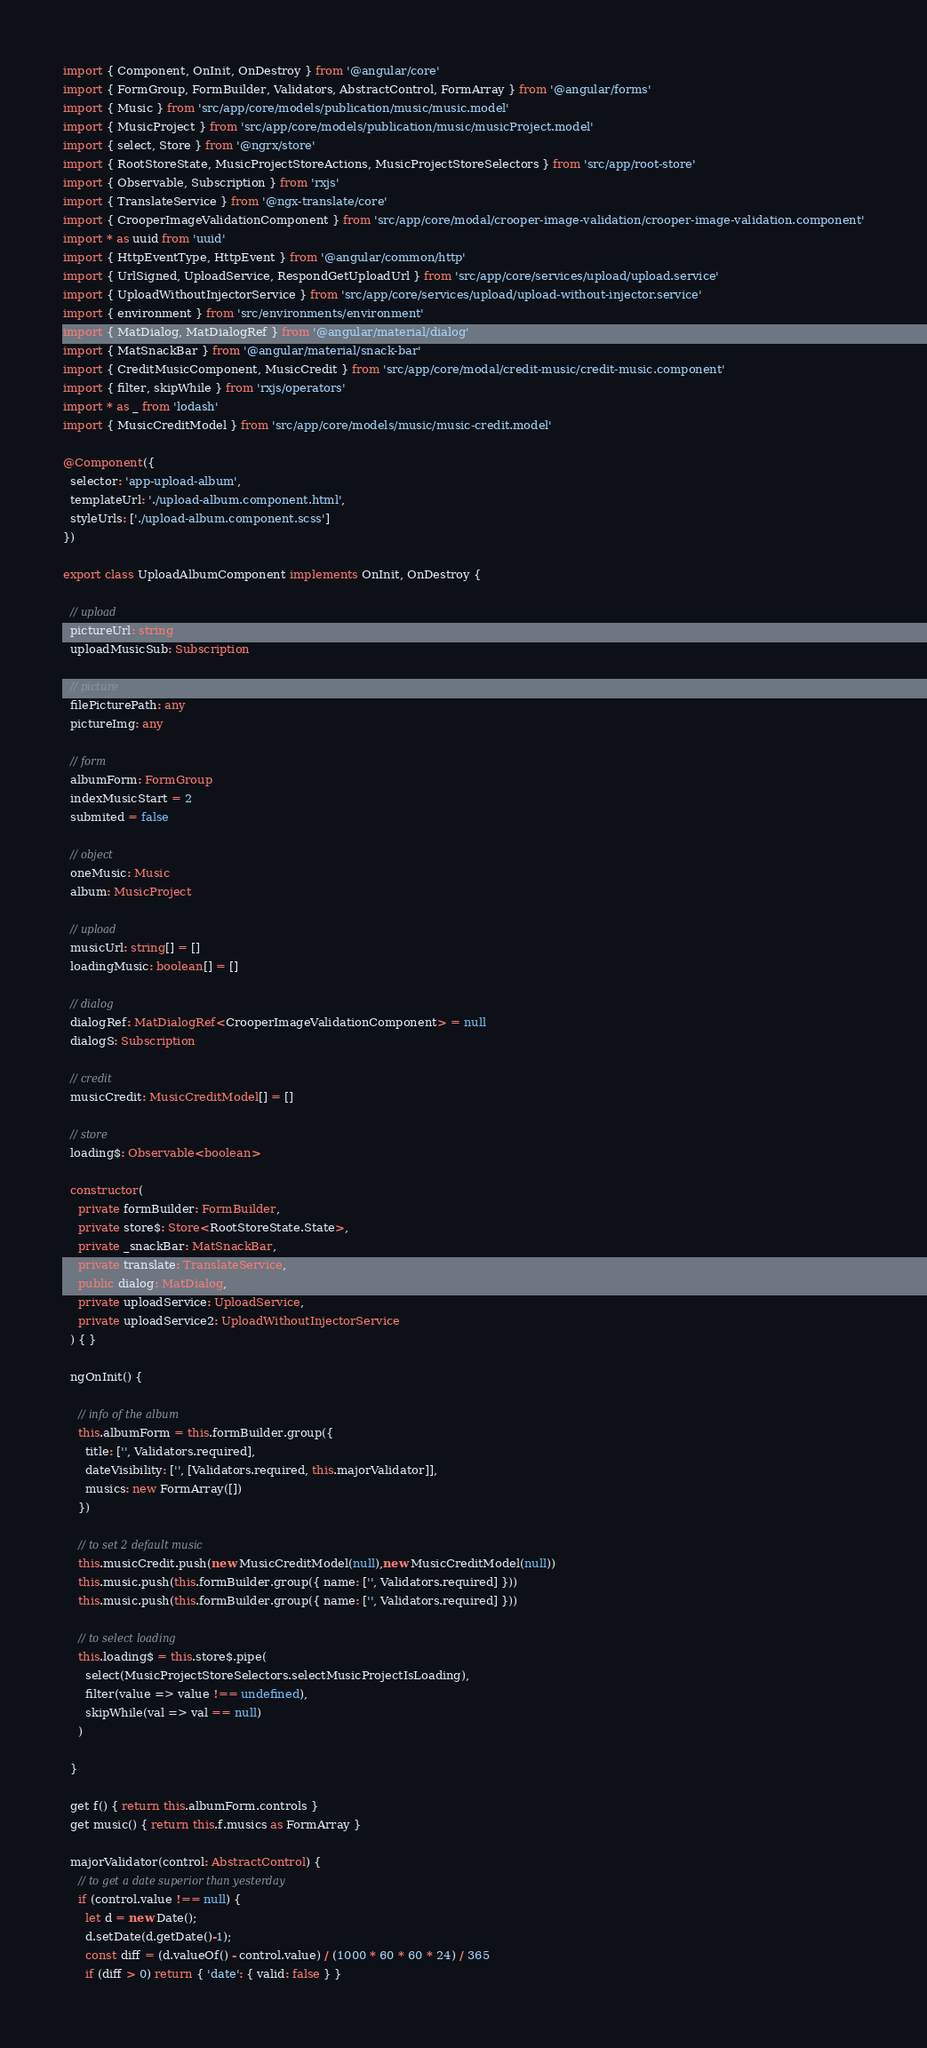Convert code to text. <code><loc_0><loc_0><loc_500><loc_500><_TypeScript_>import { Component, OnInit, OnDestroy } from '@angular/core'
import { FormGroup, FormBuilder, Validators, AbstractControl, FormArray } from '@angular/forms'
import { Music } from 'src/app/core/models/publication/music/music.model'
import { MusicProject } from 'src/app/core/models/publication/music/musicProject.model'
import { select, Store } from '@ngrx/store'
import { RootStoreState, MusicProjectStoreActions, MusicProjectStoreSelectors } from 'src/app/root-store'
import { Observable, Subscription } from 'rxjs'
import { TranslateService } from '@ngx-translate/core'
import { CrooperImageValidationComponent } from 'src/app/core/modal/crooper-image-validation/crooper-image-validation.component'
import * as uuid from 'uuid'
import { HttpEventType, HttpEvent } from '@angular/common/http'
import { UrlSigned, UploadService, RespondGetUploadUrl } from 'src/app/core/services/upload/upload.service'
import { UploadWithoutInjectorService } from 'src/app/core/services/upload/upload-without-injector.service'
import { environment } from 'src/environments/environment'
import { MatDialog, MatDialogRef } from '@angular/material/dialog'
import { MatSnackBar } from '@angular/material/snack-bar'
import { CreditMusicComponent, MusicCredit } from 'src/app/core/modal/credit-music/credit-music.component'
import { filter, skipWhile } from 'rxjs/operators'
import * as _ from 'lodash'
import { MusicCreditModel } from 'src/app/core/models/music/music-credit.model'

@Component({
  selector: 'app-upload-album',
  templateUrl: './upload-album.component.html',
  styleUrls: ['./upload-album.component.scss']
})

export class UploadAlbumComponent implements OnInit, OnDestroy {

  // upload
  pictureUrl: string
  uploadMusicSub: Subscription

  // picture
  filePicturePath: any
  pictureImg: any

  // form
  albumForm: FormGroup
  indexMusicStart = 2
  submited = false

  // object
  oneMusic: Music
  album: MusicProject

  // upload
  musicUrl: string[] = []
  loadingMusic: boolean[] = []

  // dialog
  dialogRef: MatDialogRef<CrooperImageValidationComponent> = null
  dialogS: Subscription

  // credit
  musicCredit: MusicCreditModel[] = []

  // store
  loading$: Observable<boolean>

  constructor(
    private formBuilder: FormBuilder,
    private store$: Store<RootStoreState.State>,
    private _snackBar: MatSnackBar,
    private translate: TranslateService,
    public dialog: MatDialog,
    private uploadService: UploadService,
    private uploadService2: UploadWithoutInjectorService
  ) { }

  ngOnInit() {

    // info of the album
    this.albumForm = this.formBuilder.group({
      title: ['', Validators.required],
      dateVisibility: ['', [Validators.required, this.majorValidator]],
      musics: new FormArray([])
    })

    // to set 2 default music
    this.musicCredit.push(new MusicCreditModel(null),new MusicCreditModel(null))
    this.music.push(this.formBuilder.group({ name: ['', Validators.required] }))
    this.music.push(this.formBuilder.group({ name: ['', Validators.required] }))

    // to select loading
    this.loading$ = this.store$.pipe(
      select(MusicProjectStoreSelectors.selectMusicProjectIsLoading),
      filter(value => value !== undefined),
      skipWhile(val => val == null)
    )

  }

  get f() { return this.albumForm.controls }
  get music() { return this.f.musics as FormArray }

  majorValidator(control: AbstractControl) {
    // to get a date superior than yesterday
    if (control.value !== null) {
      let d = new Date();
      d.setDate(d.getDate()-1);
      const diff = (d.valueOf() - control.value) / (1000 * 60 * 60 * 24) / 365
      if (diff > 0) return { 'date': { valid: false } }</code> 